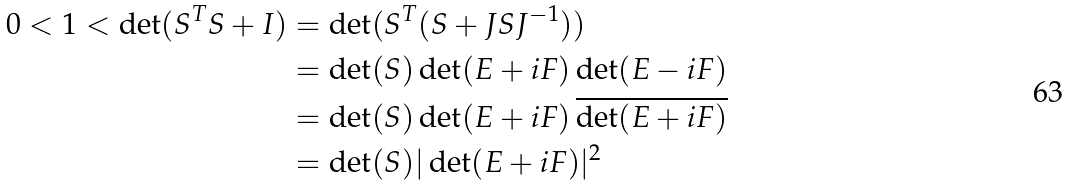Convert formula to latex. <formula><loc_0><loc_0><loc_500><loc_500>0 < 1 < \det ( S ^ { T } S + I ) & = \det ( S ^ { T } ( S + J S J ^ { - 1 } ) ) \\ & = \det ( S ) \det ( E + i F ) \det ( E - i F ) \\ & = \det ( S ) \det ( E + i F ) \, \overline { \det ( E + i F ) } \\ & = \det ( S ) | \det ( E + i F ) | ^ { 2 }</formula> 